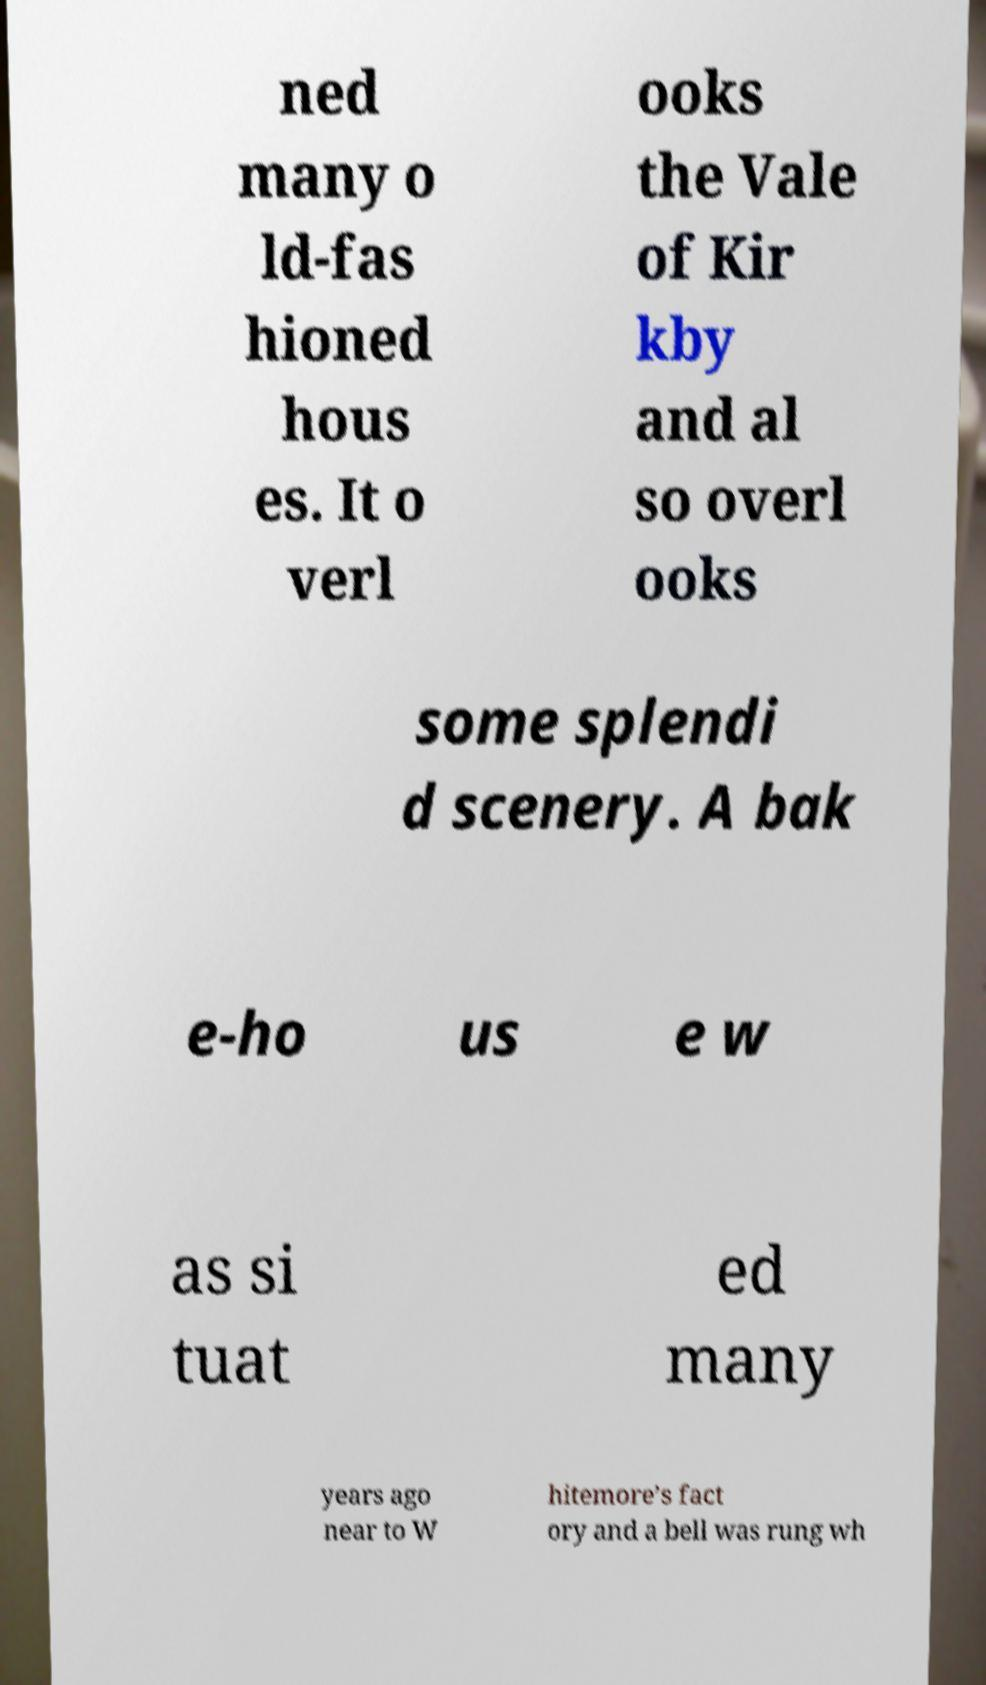There's text embedded in this image that I need extracted. Can you transcribe it verbatim? ned many o ld-fas hioned hous es. It o verl ooks the Vale of Kir kby and al so overl ooks some splendi d scenery. A bak e-ho us e w as si tuat ed many years ago near to W hitemore’s fact ory and a bell was rung wh 